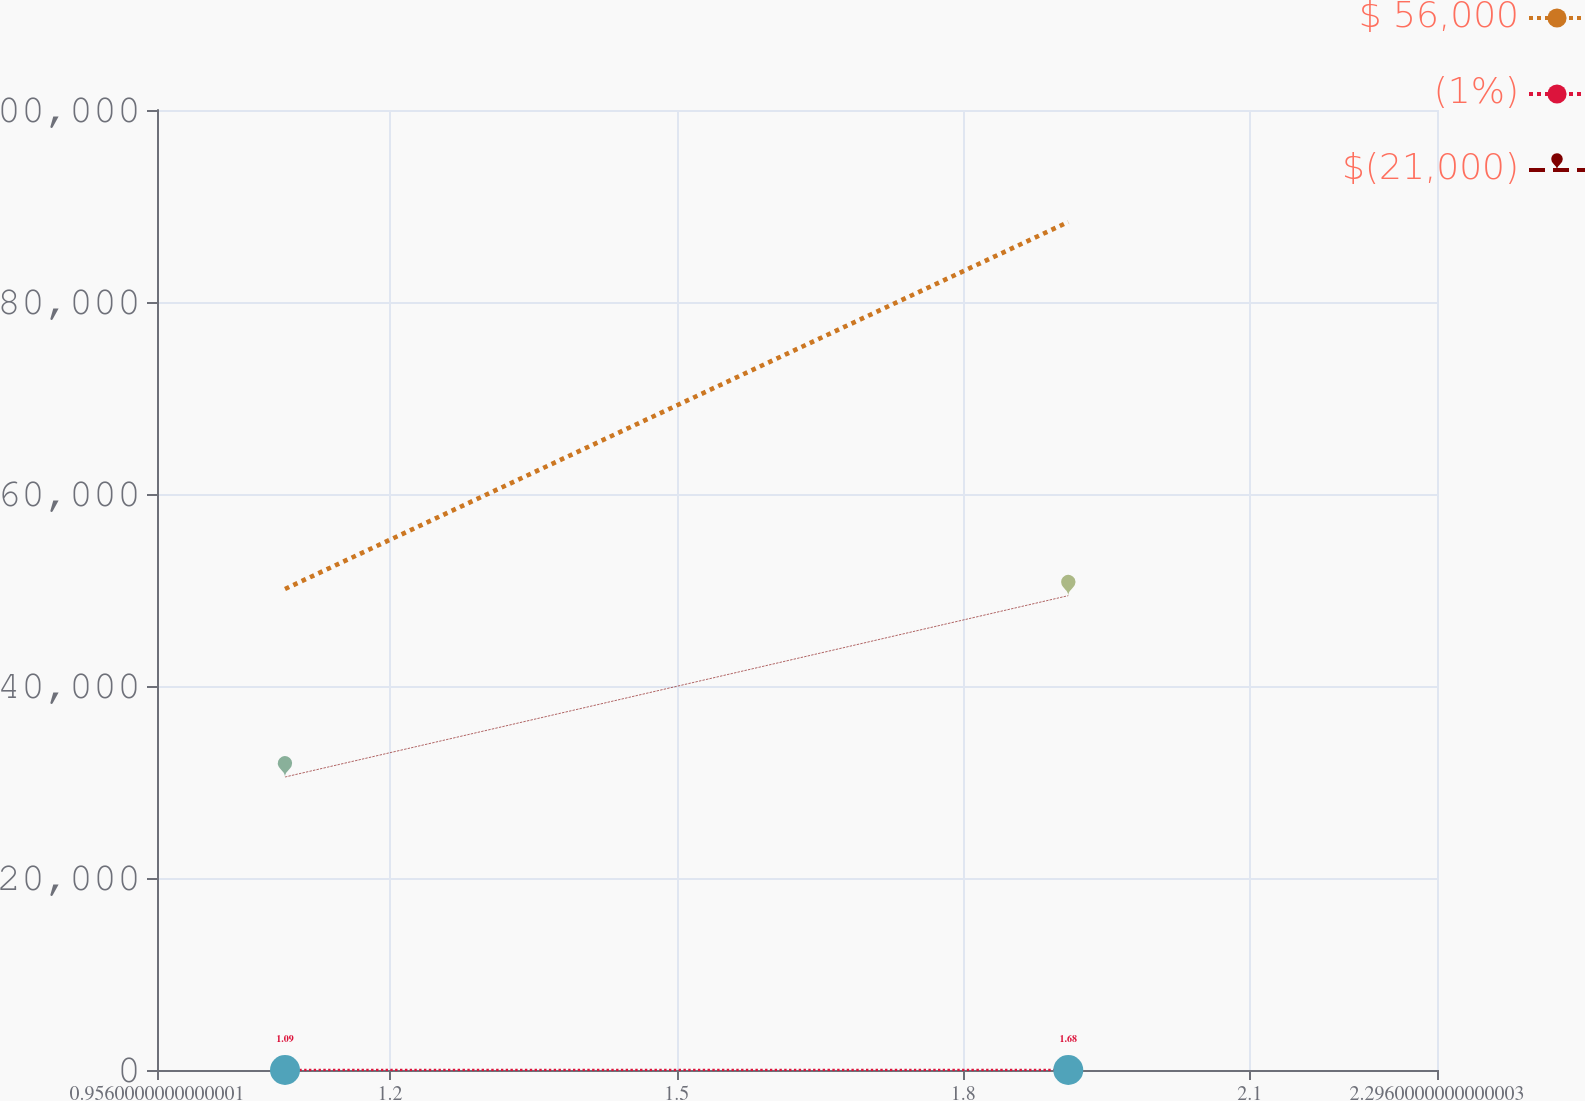Convert chart to OTSL. <chart><loc_0><loc_0><loc_500><loc_500><line_chart><ecel><fcel>$ 56,000<fcel>(1%)<fcel>$(21,000)<nl><fcel>1.09<fcel>50108.3<fcel>1.09<fcel>30520.6<nl><fcel>1.91<fcel>88334.2<fcel>1.68<fcel>49409.7<nl><fcel>2.43<fcel>165001<fcel>2.87<fcel>68399.8<nl></chart> 